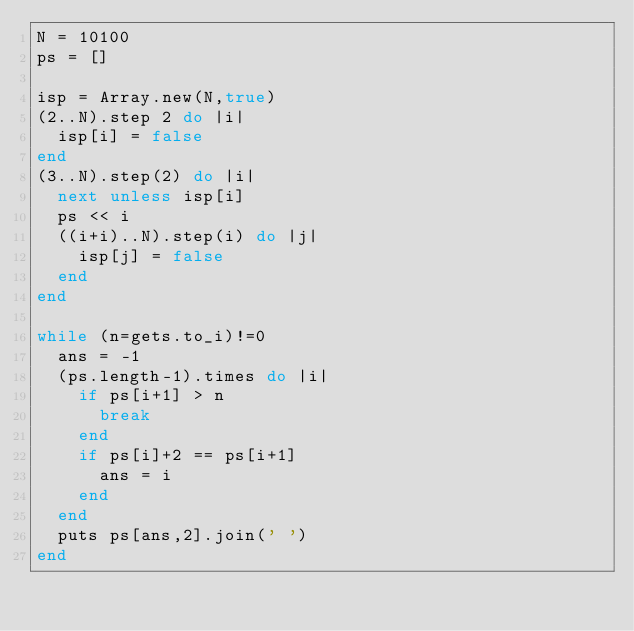Convert code to text. <code><loc_0><loc_0><loc_500><loc_500><_Ruby_>N = 10100
ps = []

isp = Array.new(N,true)
(2..N).step 2 do |i|
  isp[i] = false
end
(3..N).step(2) do |i|
  next unless isp[i]
  ps << i
  ((i+i)..N).step(i) do |j|
    isp[j] = false
  end
end

while (n=gets.to_i)!=0
  ans = -1
  (ps.length-1).times do |i|
    if ps[i+1] > n
      break
    end
    if ps[i]+2 == ps[i+1]
      ans = i
    end
  end
  puts ps[ans,2].join(' ')
end</code> 